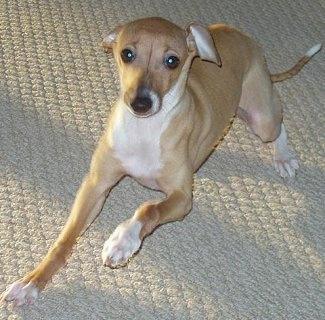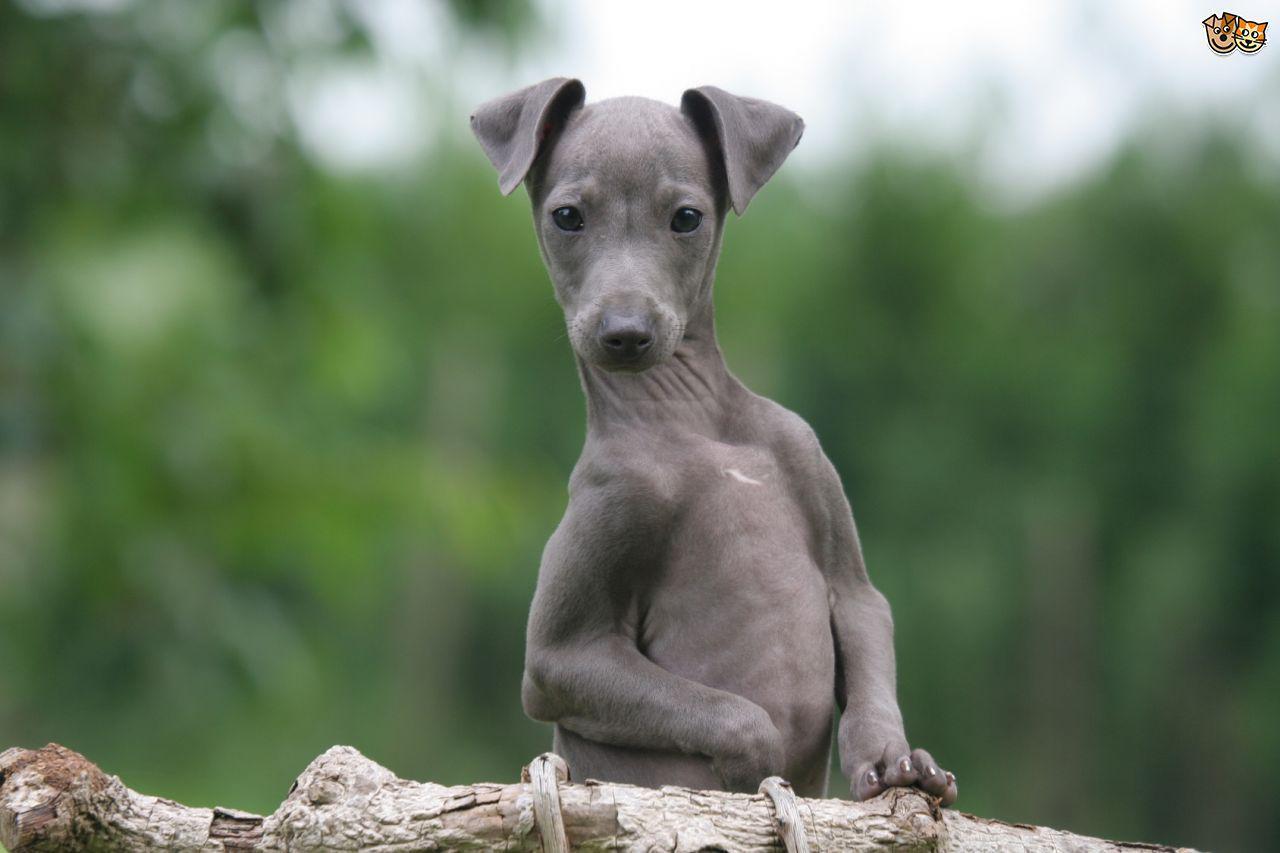The first image is the image on the left, the second image is the image on the right. Assess this claim about the two images: "An image shows one hound posed human-like, with upright head, facing the camera.". Correct or not? Answer yes or no. Yes. The first image is the image on the left, the second image is the image on the right. Assess this claim about the two images: "One of the dogs is standing on all fours in the grass.". Correct or not? Answer yes or no. No. 